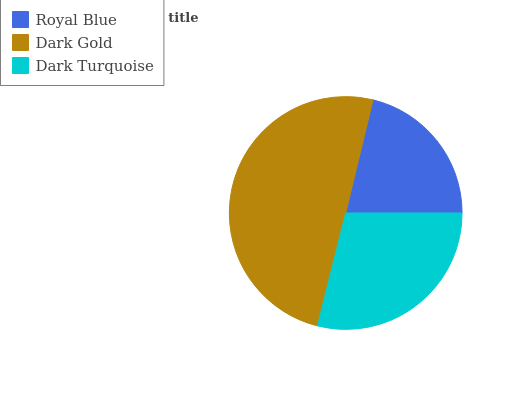Is Royal Blue the minimum?
Answer yes or no. Yes. Is Dark Gold the maximum?
Answer yes or no. Yes. Is Dark Turquoise the minimum?
Answer yes or no. No. Is Dark Turquoise the maximum?
Answer yes or no. No. Is Dark Gold greater than Dark Turquoise?
Answer yes or no. Yes. Is Dark Turquoise less than Dark Gold?
Answer yes or no. Yes. Is Dark Turquoise greater than Dark Gold?
Answer yes or no. No. Is Dark Gold less than Dark Turquoise?
Answer yes or no. No. Is Dark Turquoise the high median?
Answer yes or no. Yes. Is Dark Turquoise the low median?
Answer yes or no. Yes. Is Dark Gold the high median?
Answer yes or no. No. Is Dark Gold the low median?
Answer yes or no. No. 